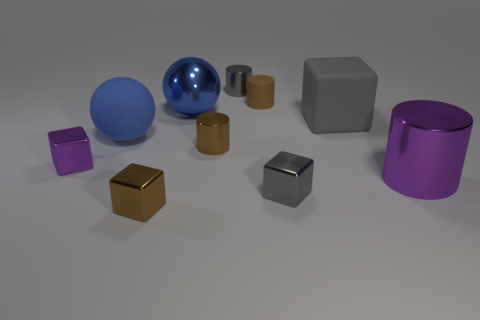How big is the blue shiny thing?
Give a very brief answer. Large. Is the number of brown rubber cylinders that are behind the tiny brown matte cylinder the same as the number of cyan cylinders?
Offer a very short reply. Yes. What number of other objects are there of the same color as the large metallic cylinder?
Give a very brief answer. 1. There is a cylinder that is both to the left of the matte block and in front of the tiny brown matte cylinder; what is its color?
Your answer should be very brief. Brown. What is the size of the cube right of the tiny gray shiny thing that is in front of the tiny brown cylinder in front of the large matte block?
Provide a short and direct response. Large. How many objects are purple objects on the left side of the brown metallic cube or small blocks behind the gray metallic cube?
Provide a short and direct response. 1. There is a tiny brown rubber object; what shape is it?
Your answer should be very brief. Cylinder. How many other objects are the same material as the big cylinder?
Offer a very short reply. 6. The other thing that is the same shape as the big blue metal object is what size?
Your answer should be compact. Large. There is a small gray thing that is to the left of the brown thing that is behind the large blue ball right of the blue rubber ball; what is its material?
Offer a terse response. Metal. 